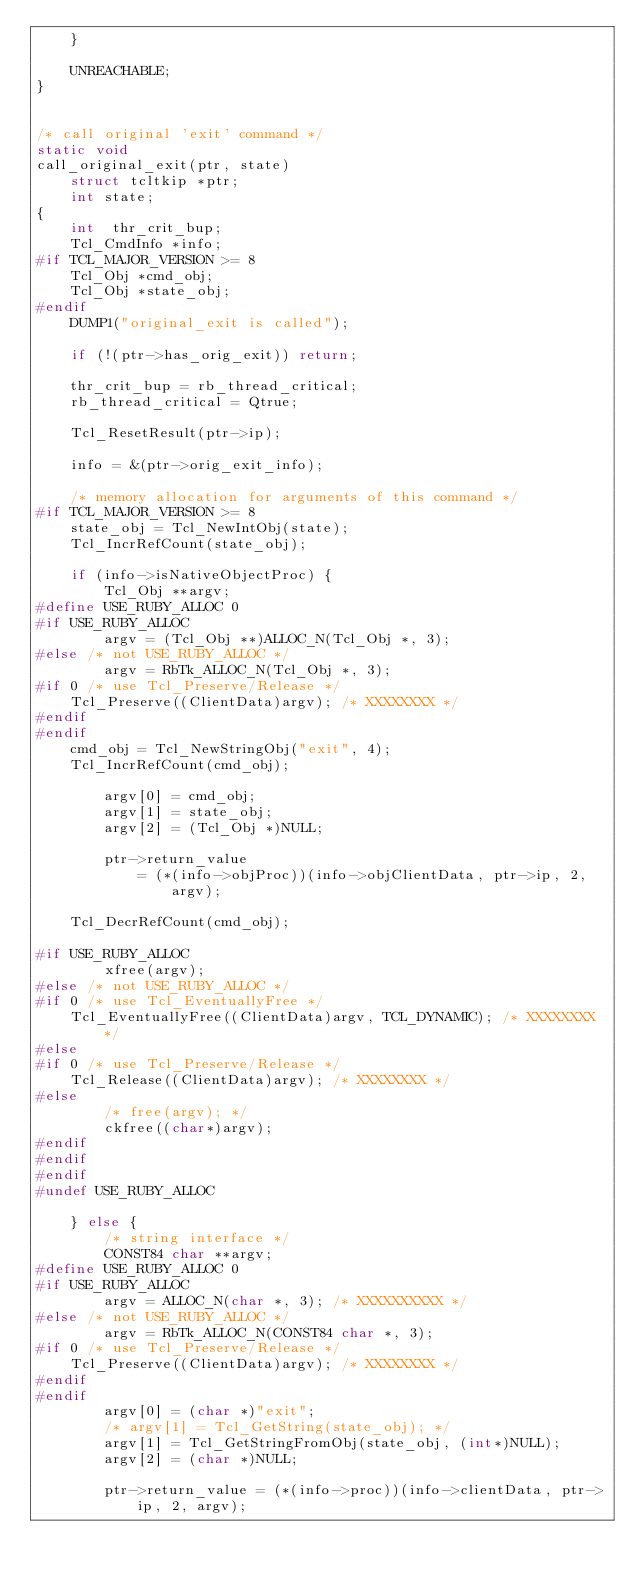Convert code to text. <code><loc_0><loc_0><loc_500><loc_500><_C_>    }

    UNREACHABLE;
}


/* call original 'exit' command */
static void
call_original_exit(ptr, state)
    struct tcltkip *ptr;
    int state;
{
    int  thr_crit_bup;
    Tcl_CmdInfo *info;
#if TCL_MAJOR_VERSION >= 8
    Tcl_Obj *cmd_obj;
    Tcl_Obj *state_obj;
#endif
    DUMP1("original_exit is called");

    if (!(ptr->has_orig_exit)) return;

    thr_crit_bup = rb_thread_critical;
    rb_thread_critical = Qtrue;

    Tcl_ResetResult(ptr->ip);

    info = &(ptr->orig_exit_info);

    /* memory allocation for arguments of this command */
#if TCL_MAJOR_VERSION >= 8
    state_obj = Tcl_NewIntObj(state);
    Tcl_IncrRefCount(state_obj);

    if (info->isNativeObjectProc) {
        Tcl_Obj **argv;
#define USE_RUBY_ALLOC 0
#if USE_RUBY_ALLOC
        argv = (Tcl_Obj **)ALLOC_N(Tcl_Obj *, 3);
#else /* not USE_RUBY_ALLOC */
        argv = RbTk_ALLOC_N(Tcl_Obj *, 3);
#if 0 /* use Tcl_Preserve/Release */
	Tcl_Preserve((ClientData)argv); /* XXXXXXXX */
#endif
#endif
	cmd_obj = Tcl_NewStringObj("exit", 4);
	Tcl_IncrRefCount(cmd_obj);

        argv[0] = cmd_obj;
        argv[1] = state_obj;
        argv[2] = (Tcl_Obj *)NULL;

        ptr->return_value
            = (*(info->objProc))(info->objClientData, ptr->ip, 2, argv);

	Tcl_DecrRefCount(cmd_obj);

#if USE_RUBY_ALLOC
        xfree(argv);
#else /* not USE_RUBY_ALLOC */
#if 0 /* use Tcl_EventuallyFree */
	Tcl_EventuallyFree((ClientData)argv, TCL_DYNAMIC); /* XXXXXXXX */
#else
#if 0 /* use Tcl_Preserve/Release */
	Tcl_Release((ClientData)argv); /* XXXXXXXX */
#else
        /* free(argv); */
        ckfree((char*)argv);
#endif
#endif
#endif
#undef USE_RUBY_ALLOC

    } else {
        /* string interface */
        CONST84 char **argv;
#define USE_RUBY_ALLOC 0
#if USE_RUBY_ALLOC
        argv = ALLOC_N(char *, 3); /* XXXXXXXXXX */
#else /* not USE_RUBY_ALLOC */
        argv = RbTk_ALLOC_N(CONST84 char *, 3);
#if 0 /* use Tcl_Preserve/Release */
	Tcl_Preserve((ClientData)argv); /* XXXXXXXX */
#endif
#endif
        argv[0] = (char *)"exit";
        /* argv[1] = Tcl_GetString(state_obj); */
        argv[1] = Tcl_GetStringFromObj(state_obj, (int*)NULL);
        argv[2] = (char *)NULL;

        ptr->return_value = (*(info->proc))(info->clientData, ptr->ip, 2, argv);
</code> 